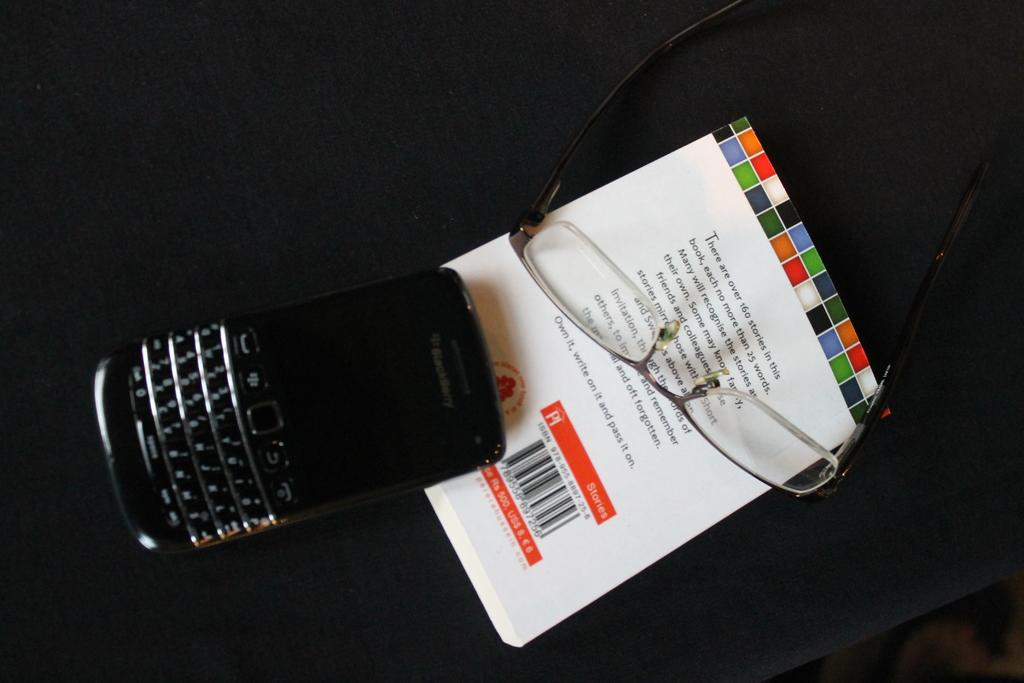<image>
Summarize the visual content of the image. The back of a book claims that it contains many stories that are all no more than 25 words. 